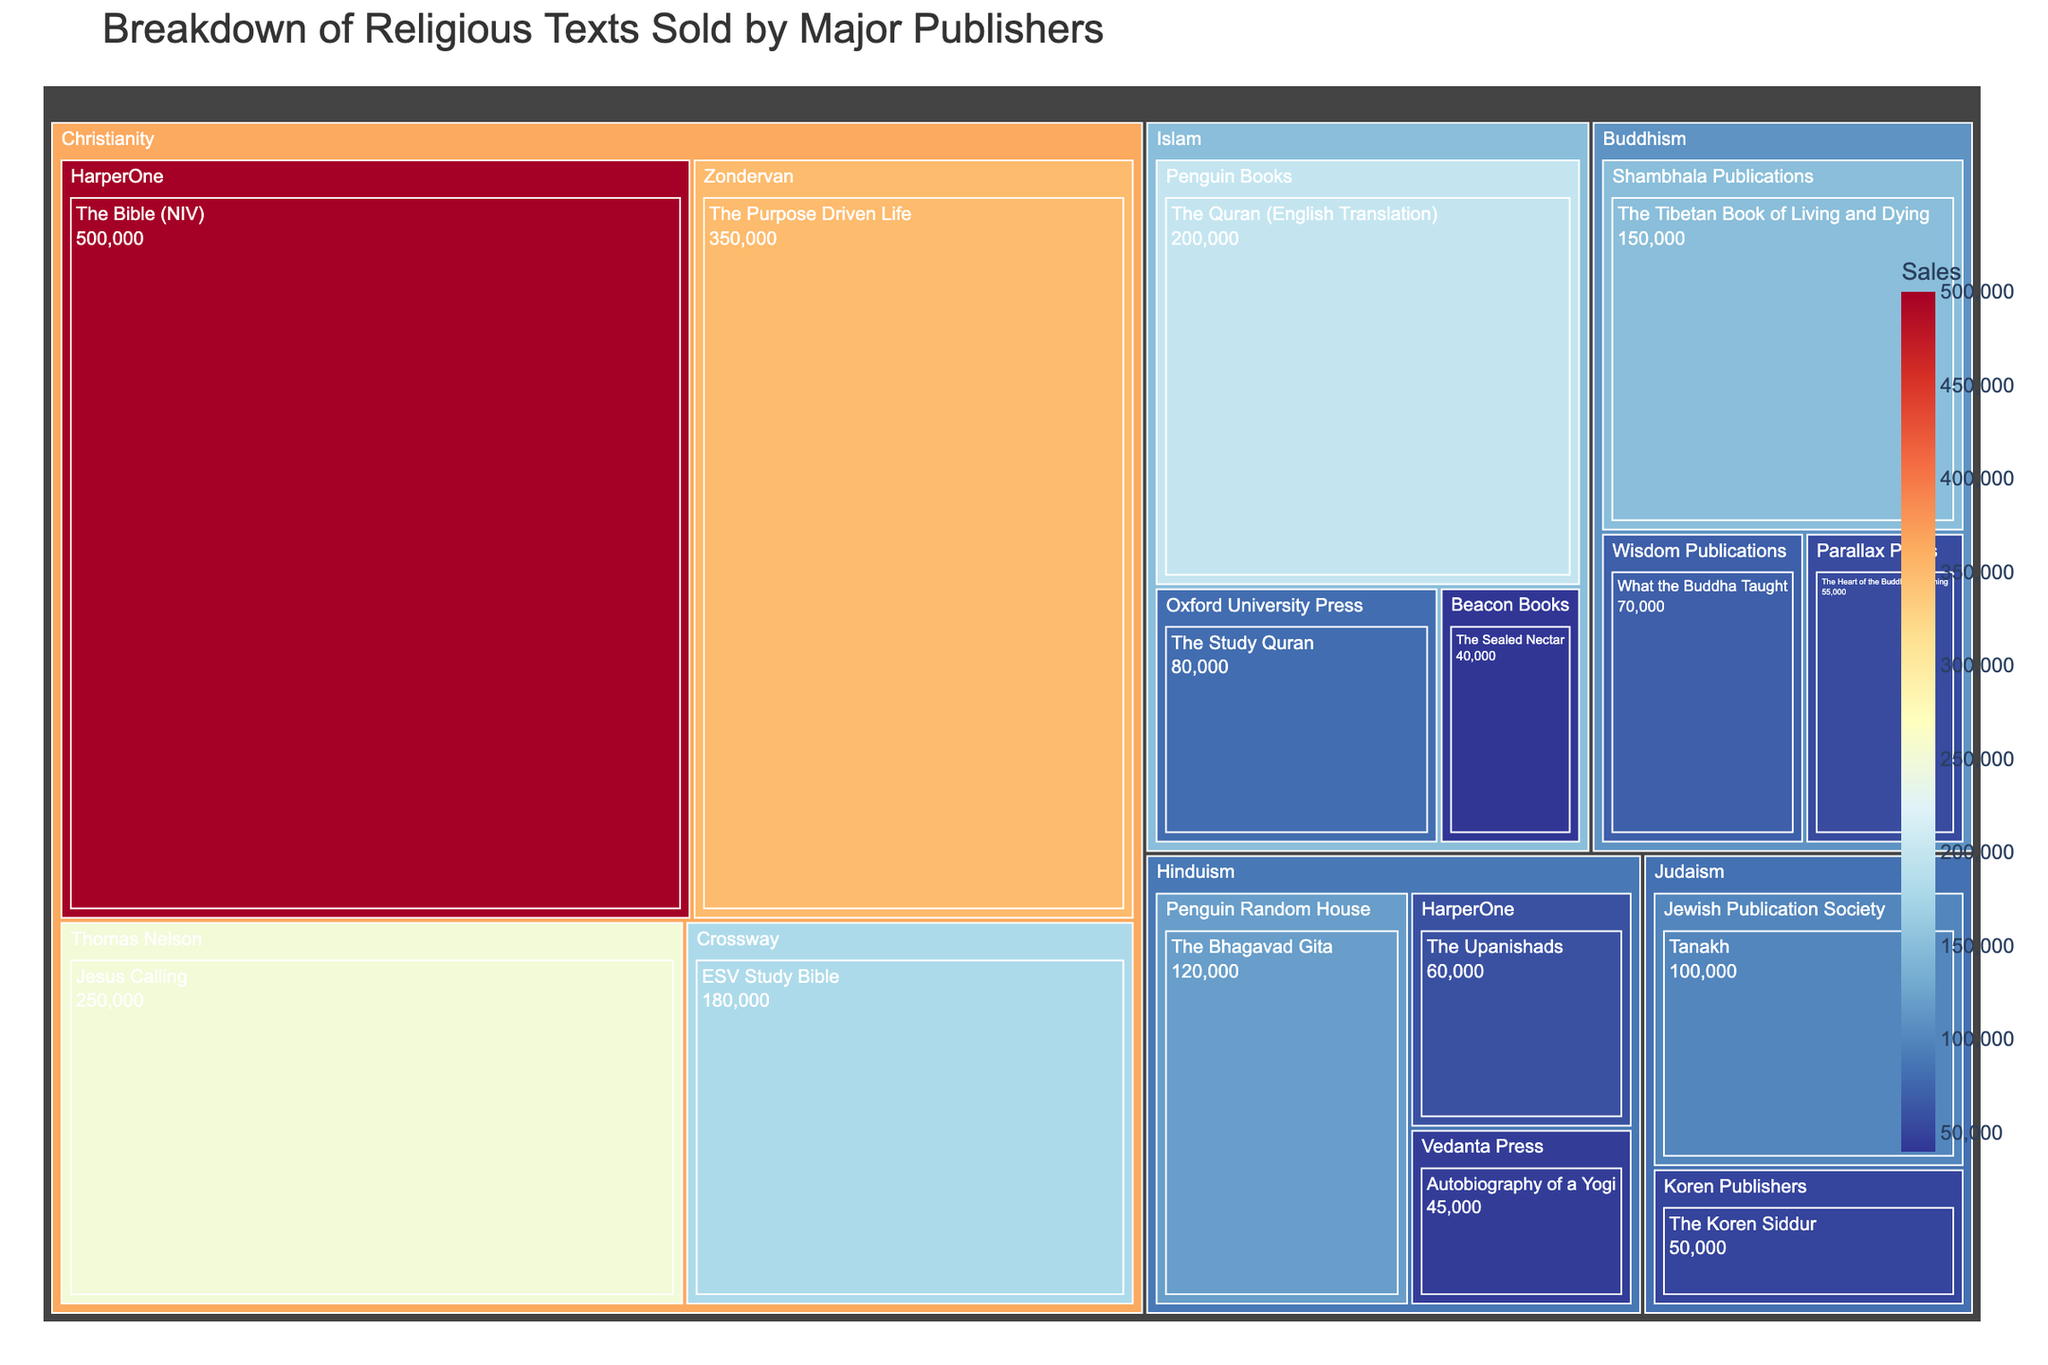What is the title of the figure? The title of the figure is usually placed at the top of the plot and is easily identifiable due to its larger and bolder font. In this case, the title provided in the code is "Breakdown of Religious Texts Sold by Major Publishers".
Answer: Breakdown of Religious Texts Sold by Major Publishers Which religious text has the highest sales? By examining the treemap, you can identify the largest block within the figure and check its label. Here, "The Bible (NIV)" published by HarperOne, within the Christianity category, has the highest sales figure of 500,000.
Answer: The Bible (NIV) What is the total sales of Christian texts? To find the total sales of Christian texts, sum up the sales values of all Christian texts in the treemap: 500,000 (NIV) + 350,000 (The Purpose Driven Life) + 250,000 (Jesus Calling) + 180,000 (ESV Study Bible). This equals 1,280,000.
Answer: 1,280,000 Which publisher has the most diverse set of religious texts in terms of different religions? Identifying diversity means finding the publisher associated with multiple different religions. HarperOne appears in both Christianity and Hinduism categories, signifying diversity in terms of religious types published.
Answer: HarperOne How many publishers are involved in the sales of Islamic texts? The treemap visualizes this clearly with distinct blocks for each publisher under the Islam category. By counting these blocks, one can see there are three publishers: Penguin Books, Oxford University Press, and Beacon Books.
Answer: Three What is the average sales volume of Buddhist texts? The average is calculated by taking the sum of sales of Buddhist texts and dividing by the number of texts. Summing: 150,000 + 70,000 + 55,000 = 275,000. Number of texts: 3. So, the average is 275,000 / 3 = 91,667.
Answer: 91,667 Which religious text in the Hinduism category has the lowest sales? Check the sales figures for all Hindu texts within the treemap and identify the lowest value. "Autobiography of a Yogi" published by Vedanta Press has the lowest sales figure of 45,000.
Answer: Autobiography of a Yogi Compare the sales figures between the highest-selling Christian and highest-selling Islamic texts. Which one has higher sales and by how much? The highest-selling Christian text is "The Bible (NIV)" with 500,000 sales. The highest-selling Islamic text is "The Quran (English Translation)" with 200,000 sales. The difference is 500,000 - 200,000 = 300,000.
Answer: The Bible (NIV) by 300,000 Which category has the least total sales and what is that figure? Sum the sales figures within each category. Judaism: 100,000 + 50,000 = 150,000. The lowest total sales among all categories are found in Judaism.
Answer: Judaism with 150,000 What is the combined sales figure for the texts published by Penguin Books and Penguin Random House? Add the sales figures for texts under both publishers: Penguin Books (200,000) + Penguin Random House (120,000) = 320,000.
Answer: 320,000 